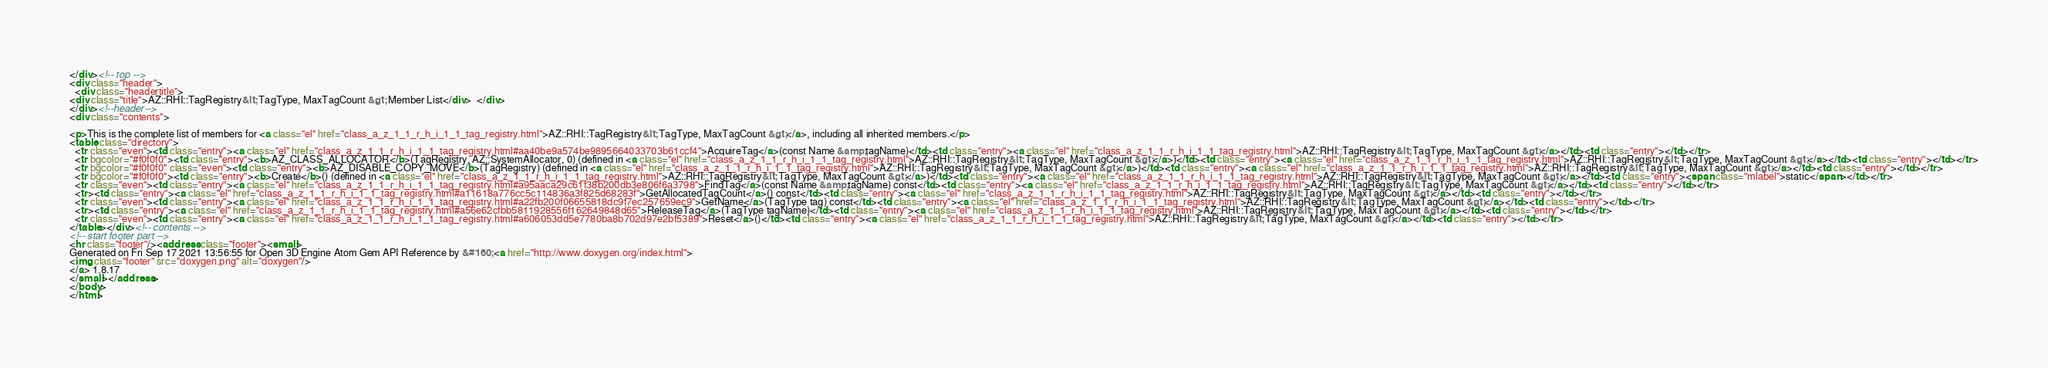<code> <loc_0><loc_0><loc_500><loc_500><_HTML_></div><!-- top -->
<div class="header">
  <div class="headertitle">
<div class="title">AZ::RHI::TagRegistry&lt; TagType, MaxTagCount &gt; Member List</div>  </div>
</div><!--header-->
<div class="contents">

<p>This is the complete list of members for <a class="el" href="class_a_z_1_1_r_h_i_1_1_tag_registry.html">AZ::RHI::TagRegistry&lt; TagType, MaxTagCount &gt;</a>, including all inherited members.</p>
<table class="directory">
  <tr class="even"><td class="entry"><a class="el" href="class_a_z_1_1_r_h_i_1_1_tag_registry.html#aa40be9a574be9895664033703b61ccf4">AcquireTag</a>(const Name &amp;tagName)</td><td class="entry"><a class="el" href="class_a_z_1_1_r_h_i_1_1_tag_registry.html">AZ::RHI::TagRegistry&lt; TagType, MaxTagCount &gt;</a></td><td class="entry"></td></tr>
  <tr bgcolor="#f0f0f0"><td class="entry"><b>AZ_CLASS_ALLOCATOR</b>(TagRegistry, AZ::SystemAllocator, 0) (defined in <a class="el" href="class_a_z_1_1_r_h_i_1_1_tag_registry.html">AZ::RHI::TagRegistry&lt; TagType, MaxTagCount &gt;</a>)</td><td class="entry"><a class="el" href="class_a_z_1_1_r_h_i_1_1_tag_registry.html">AZ::RHI::TagRegistry&lt; TagType, MaxTagCount &gt;</a></td><td class="entry"></td></tr>
  <tr bgcolor="#f0f0f0" class="even"><td class="entry"><b>AZ_DISABLE_COPY_MOVE</b>(TagRegistry) (defined in <a class="el" href="class_a_z_1_1_r_h_i_1_1_tag_registry.html">AZ::RHI::TagRegistry&lt; TagType, MaxTagCount &gt;</a>)</td><td class="entry"><a class="el" href="class_a_z_1_1_r_h_i_1_1_tag_registry.html">AZ::RHI::TagRegistry&lt; TagType, MaxTagCount &gt;</a></td><td class="entry"></td></tr>
  <tr bgcolor="#f0f0f0"><td class="entry"><b>Create</b>() (defined in <a class="el" href="class_a_z_1_1_r_h_i_1_1_tag_registry.html">AZ::RHI::TagRegistry&lt; TagType, MaxTagCount &gt;</a>)</td><td class="entry"><a class="el" href="class_a_z_1_1_r_h_i_1_1_tag_registry.html">AZ::RHI::TagRegistry&lt; TagType, MaxTagCount &gt;</a></td><td class="entry"><span class="mlabel">static</span></td></tr>
  <tr class="even"><td class="entry"><a class="el" href="class_a_z_1_1_r_h_i_1_1_tag_registry.html#a95aaca29c61f38b200db3e806f6a3798">FindTag</a>(const Name &amp;tagName) const</td><td class="entry"><a class="el" href="class_a_z_1_1_r_h_i_1_1_tag_registry.html">AZ::RHI::TagRegistry&lt; TagType, MaxTagCount &gt;</a></td><td class="entry"></td></tr>
  <tr><td class="entry"><a class="el" href="class_a_z_1_1_r_h_i_1_1_tag_registry.html#a11618a776cc5c114836a3f825d68283f">GetAllocatedTagCount</a>() const</td><td class="entry"><a class="el" href="class_a_z_1_1_r_h_i_1_1_tag_registry.html">AZ::RHI::TagRegistry&lt; TagType, MaxTagCount &gt;</a></td><td class="entry"></td></tr>
  <tr class="even"><td class="entry"><a class="el" href="class_a_z_1_1_r_h_i_1_1_tag_registry.html#a22fb200f06655818dc9f7ec257659ec9">GetName</a>(TagType tag) const</td><td class="entry"><a class="el" href="class_a_z_1_1_r_h_i_1_1_tag_registry.html">AZ::RHI::TagRegistry&lt; TagType, MaxTagCount &gt;</a></td><td class="entry"></td></tr>
  <tr><td class="entry"><a class="el" href="class_a_z_1_1_r_h_i_1_1_tag_registry.html#a56e62cfbb5811928556f162649848d65">ReleaseTag</a>(TagType tagName)</td><td class="entry"><a class="el" href="class_a_z_1_1_r_h_i_1_1_tag_registry.html">AZ::RHI::TagRegistry&lt; TagType, MaxTagCount &gt;</a></td><td class="entry"></td></tr>
  <tr class="even"><td class="entry"><a class="el" href="class_a_z_1_1_r_h_i_1_1_tag_registry.html#a606053dd5e7780ba8b702d97e2bf5389">Reset</a>()</td><td class="entry"><a class="el" href="class_a_z_1_1_r_h_i_1_1_tag_registry.html">AZ::RHI::TagRegistry&lt; TagType, MaxTagCount &gt;</a></td><td class="entry"></td></tr>
</table></div><!-- contents -->
<!-- start footer part -->
<hr class="footer"/><address class="footer"><small>
Generated on Fri Sep 17 2021 13:56:55 for Open 3D Engine Atom Gem API Reference by &#160;<a href="http://www.doxygen.org/index.html">
<img class="footer" src="doxygen.png" alt="doxygen"/>
</a> 1.8.17
</small></address>
</body>
</html>
</code> 